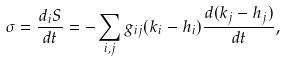<formula> <loc_0><loc_0><loc_500><loc_500>\sigma = \frac { d _ { i } S } { d t } = - \sum _ { i , j } g _ { i j } ( k _ { i } - h _ { i } ) \frac { d ( k _ { j } - h _ { j } ) } { d t } ,</formula> 